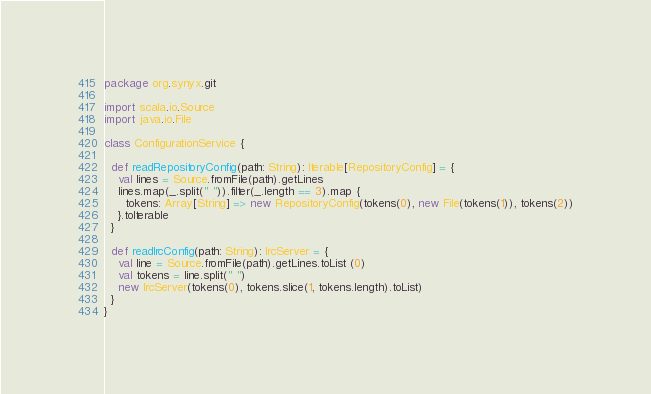<code> <loc_0><loc_0><loc_500><loc_500><_Scala_>package org.synyx.git

import scala.io.Source
import java.io.File

class ConfigurationService {

  def readRepositoryConfig(path: String): Iterable[RepositoryConfig] = {
    val lines = Source.fromFile(path).getLines
    lines.map(_.split(" ")).filter(_.length == 3).map {
      tokens: Array[String] => new RepositoryConfig(tokens(0), new File(tokens(1)), tokens(2))
    }.toIterable
  }

  def readIrcConfig(path: String): IrcServer = {
    val line = Source.fromFile(path).getLines.toList (0)
    val tokens = line.split(" ")
    new IrcServer(tokens(0), tokens.slice(1, tokens.length).toList)
  }
}
</code> 